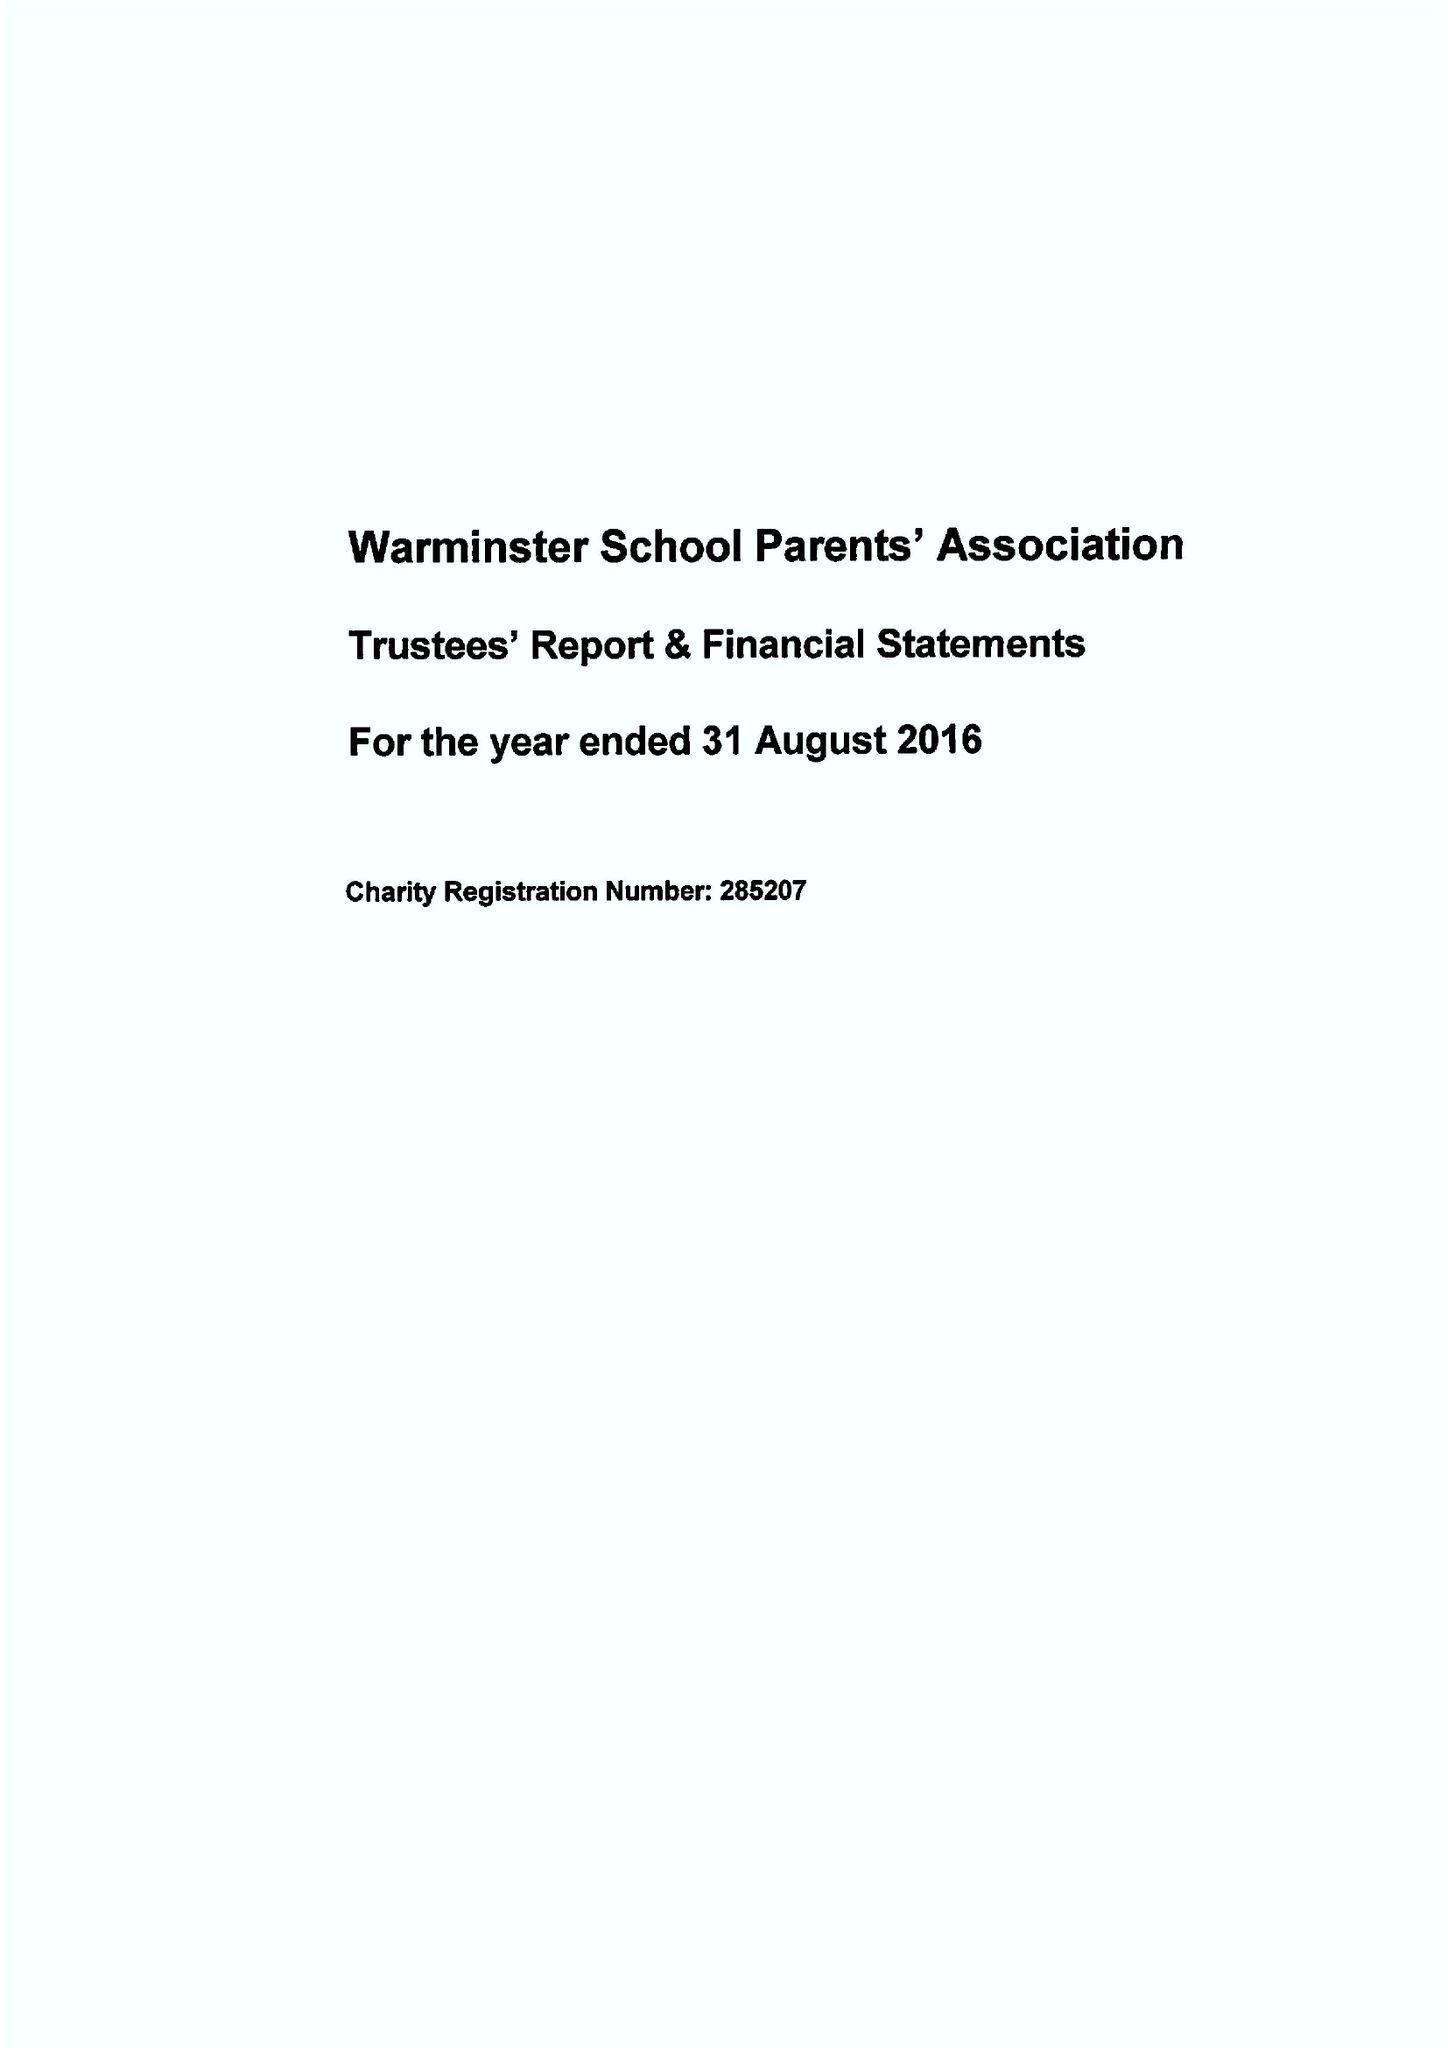What is the value for the income_annually_in_british_pounds?
Answer the question using a single word or phrase. 34661.00 